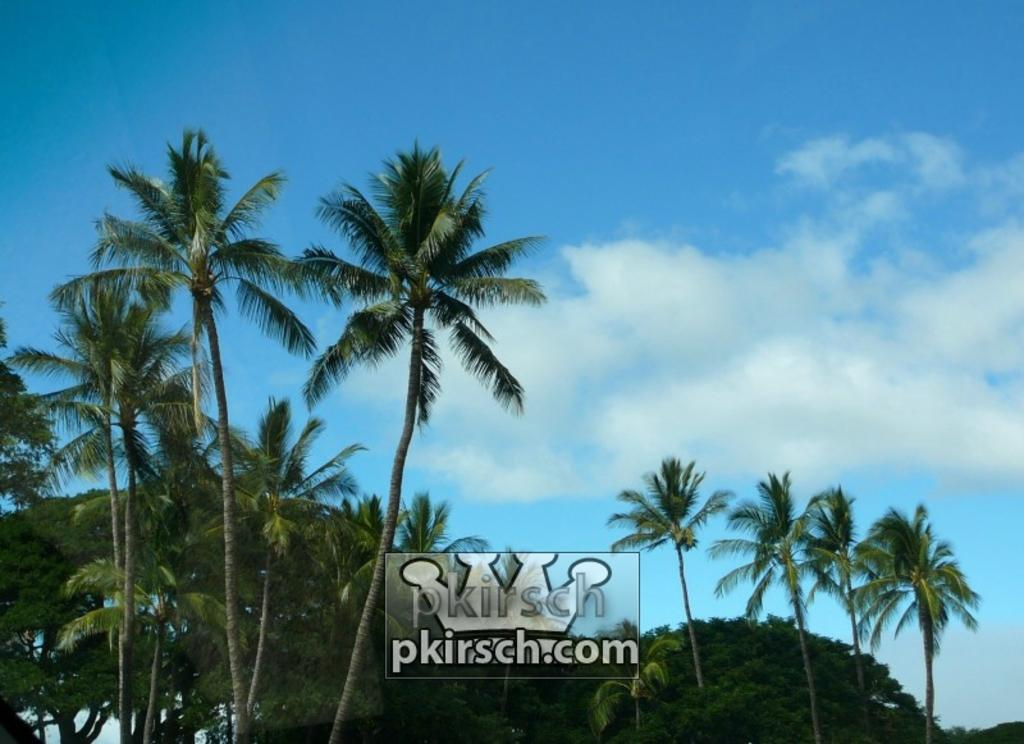What type of natural elements can be seen in the image? There are many trees in the image. Is there any text or marking visible in the image? Yes, there is a watermark in the image. What part of the natural environment is visible in the image? The sky is visible in the image. What can be seen in the sky in the image? Clouds are present in the image. How many chairs are visible in the image? There are no chairs present in the image. What type of spiders can be seen in the image? There are no spiders present in the image. 